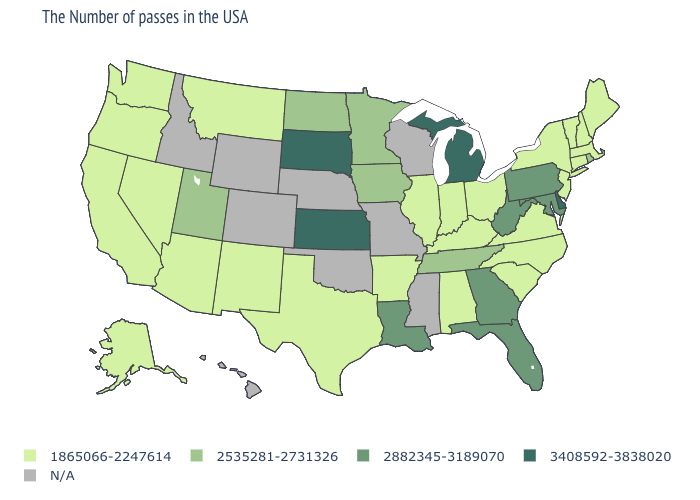Does Ohio have the highest value in the MidWest?
Quick response, please. No. Which states hav the highest value in the Northeast?
Keep it brief. Pennsylvania. What is the lowest value in the USA?
Be succinct. 1865066-2247614. Is the legend a continuous bar?
Write a very short answer. No. What is the value of Mississippi?
Keep it brief. N/A. Name the states that have a value in the range 3408592-3838020?
Be succinct. Delaware, Michigan, Kansas, South Dakota. What is the value of Alaska?
Concise answer only. 1865066-2247614. Name the states that have a value in the range N/A?
Answer briefly. Wisconsin, Mississippi, Missouri, Nebraska, Oklahoma, Wyoming, Colorado, Idaho, Hawaii. Name the states that have a value in the range 2882345-3189070?
Answer briefly. Maryland, Pennsylvania, West Virginia, Florida, Georgia, Louisiana. What is the highest value in the USA?
Quick response, please. 3408592-3838020. Does Virginia have the lowest value in the South?
Keep it brief. Yes. What is the value of Connecticut?
Keep it brief. 1865066-2247614. Does South Dakota have the highest value in the USA?
Be succinct. Yes. Among the states that border Delaware , does New Jersey have the highest value?
Short answer required. No. Name the states that have a value in the range 2882345-3189070?
Write a very short answer. Maryland, Pennsylvania, West Virginia, Florida, Georgia, Louisiana. 